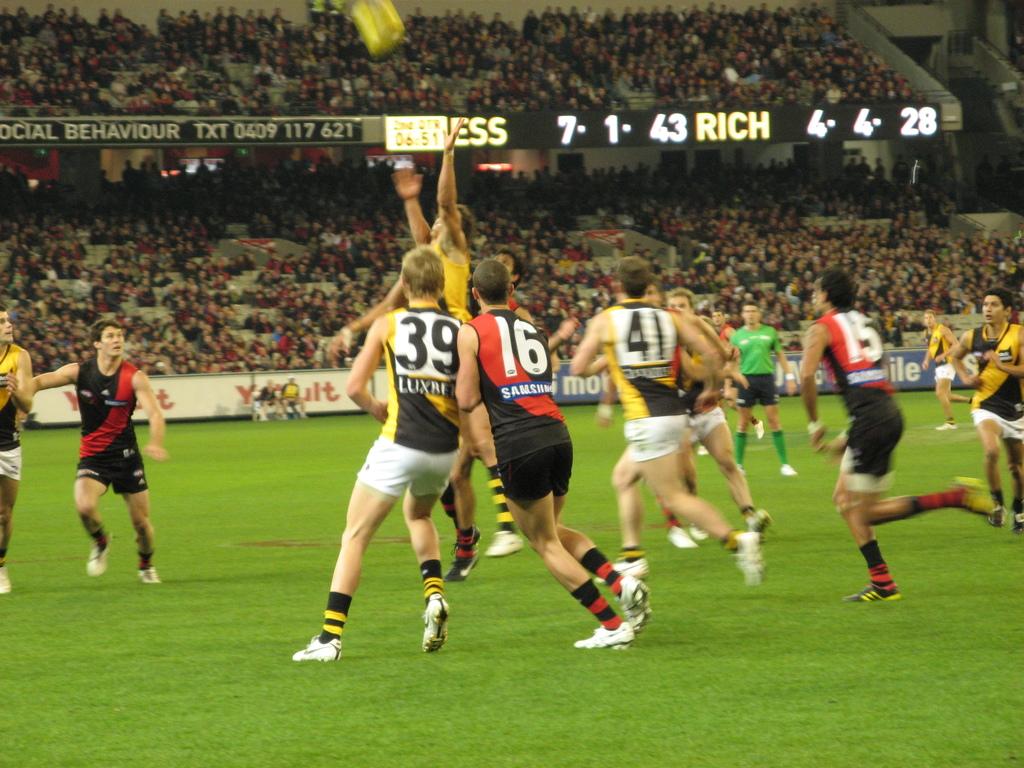What is one of the players numbers?
Your response must be concise. 39. What is the middle player's number in red?
Make the answer very short. 16. 